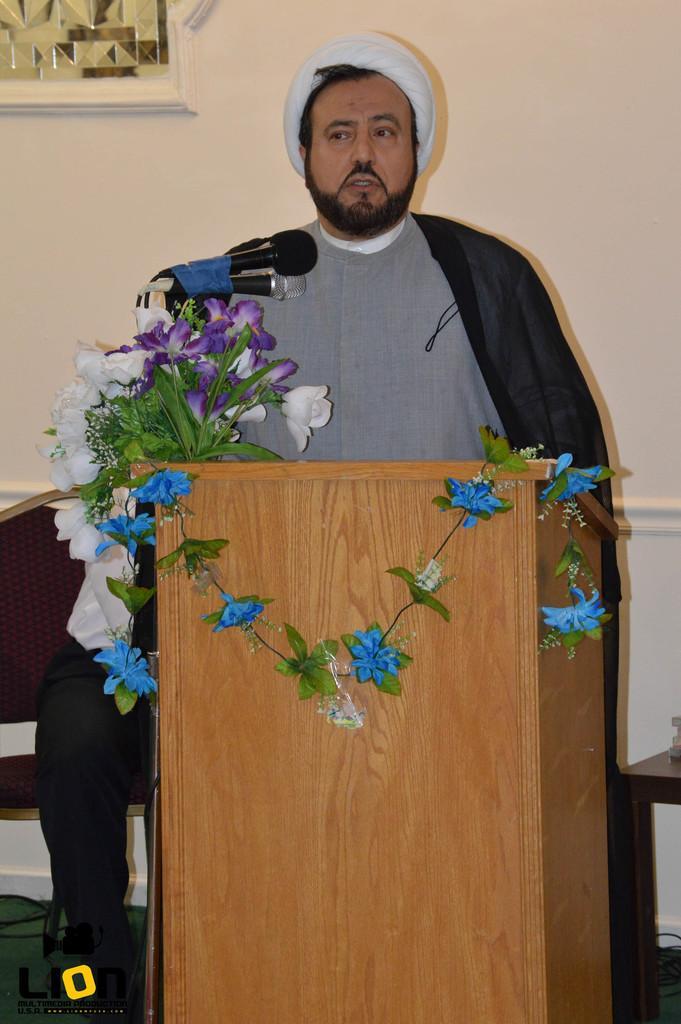Could you give a brief overview of what you see in this image? In this picture we can observe a person standing in front of a brown color podium. There are some flowers and a plant placed on this podium. We can observe a mic. In the background there is a wall which is in white color. 